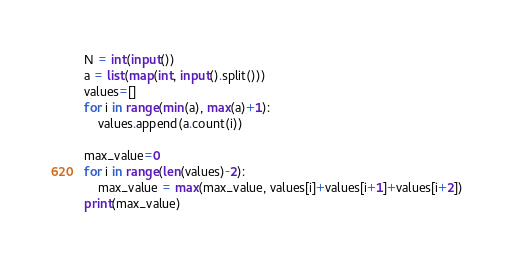Convert code to text. <code><loc_0><loc_0><loc_500><loc_500><_Python_>N = int(input())
a = list(map(int, input().split()))
values=[]
for i in range(min(a), max(a)+1):
    values.append(a.count(i))
    
max_value=0
for i in range(len(values)-2):
    max_value = max(max_value, values[i]+values[i+1]+values[i+2])
print(max_value)</code> 